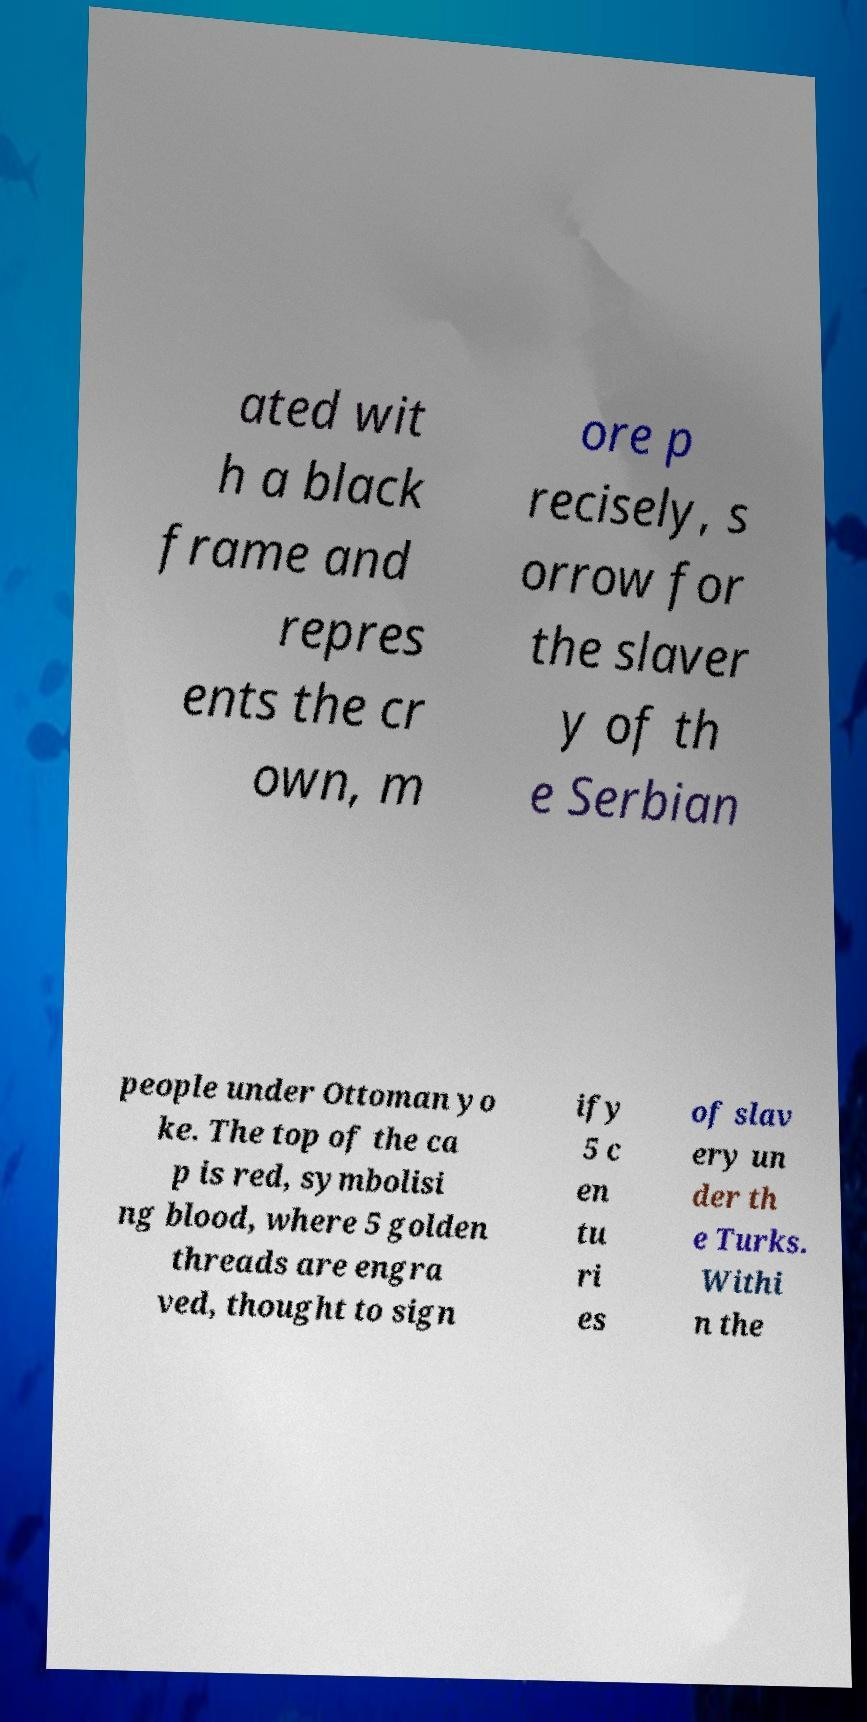Could you assist in decoding the text presented in this image and type it out clearly? ated wit h a black frame and repres ents the cr own, m ore p recisely, s orrow for the slaver y of th e Serbian people under Ottoman yo ke. The top of the ca p is red, symbolisi ng blood, where 5 golden threads are engra ved, thought to sign ify 5 c en tu ri es of slav ery un der th e Turks. Withi n the 